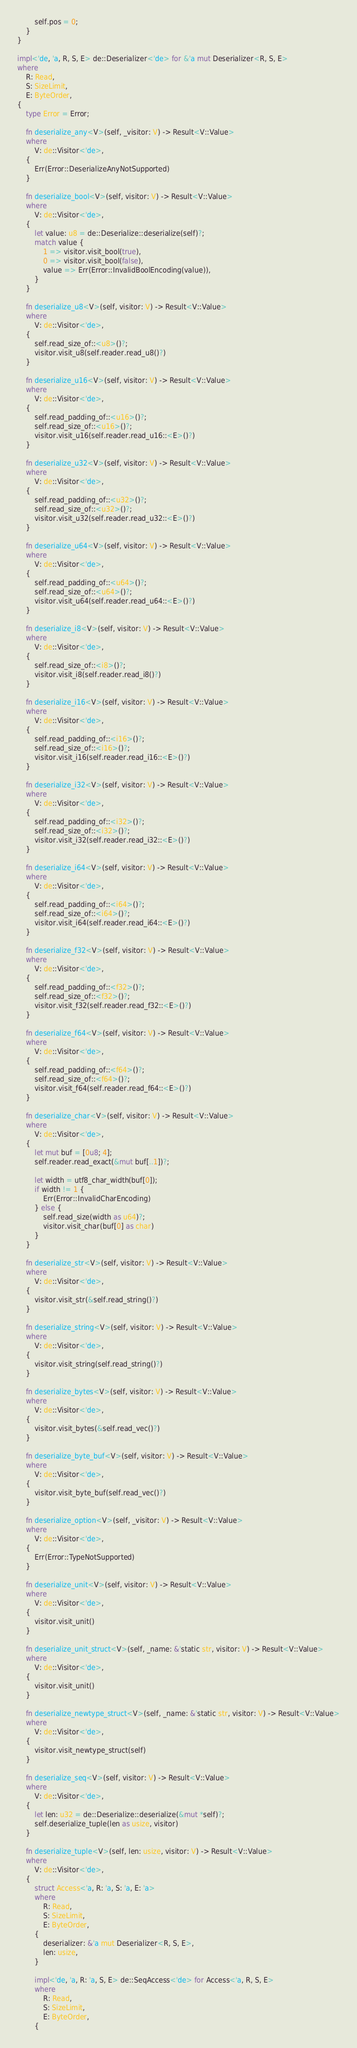Convert code to text. <code><loc_0><loc_0><loc_500><loc_500><_Rust_>        self.pos = 0;
    }
}

impl<'de, 'a, R, S, E> de::Deserializer<'de> for &'a mut Deserializer<R, S, E>
where
    R: Read,
    S: SizeLimit,
    E: ByteOrder,
{
    type Error = Error;

    fn deserialize_any<V>(self, _visitor: V) -> Result<V::Value>
    where
        V: de::Visitor<'de>,
    {
        Err(Error::DeserializeAnyNotSupported)
    }

    fn deserialize_bool<V>(self, visitor: V) -> Result<V::Value>
    where
        V: de::Visitor<'de>,
    {
        let value: u8 = de::Deserialize::deserialize(self)?;
        match value {
            1 => visitor.visit_bool(true),
            0 => visitor.visit_bool(false),
            value => Err(Error::InvalidBoolEncoding(value)),
        }
    }

    fn deserialize_u8<V>(self, visitor: V) -> Result<V::Value>
    where
        V: de::Visitor<'de>,
    {
        self.read_size_of::<u8>()?;
        visitor.visit_u8(self.reader.read_u8()?)
    }

    fn deserialize_u16<V>(self, visitor: V) -> Result<V::Value>
    where
        V: de::Visitor<'de>,
    {
        self.read_padding_of::<u16>()?;
        self.read_size_of::<u16>()?;
        visitor.visit_u16(self.reader.read_u16::<E>()?)
    }

    fn deserialize_u32<V>(self, visitor: V) -> Result<V::Value>
    where
        V: de::Visitor<'de>,
    {
        self.read_padding_of::<u32>()?;
        self.read_size_of::<u32>()?;
        visitor.visit_u32(self.reader.read_u32::<E>()?)
    }

    fn deserialize_u64<V>(self, visitor: V) -> Result<V::Value>
    where
        V: de::Visitor<'de>,
    {
        self.read_padding_of::<u64>()?;
        self.read_size_of::<u64>()?;
        visitor.visit_u64(self.reader.read_u64::<E>()?)
    }

    fn deserialize_i8<V>(self, visitor: V) -> Result<V::Value>
    where
        V: de::Visitor<'de>,
    {
        self.read_size_of::<i8>()?;
        visitor.visit_i8(self.reader.read_i8()?)
    }

    fn deserialize_i16<V>(self, visitor: V) -> Result<V::Value>
    where
        V: de::Visitor<'de>,
    {
        self.read_padding_of::<i16>()?;
        self.read_size_of::<i16>()?;
        visitor.visit_i16(self.reader.read_i16::<E>()?)
    }

    fn deserialize_i32<V>(self, visitor: V) -> Result<V::Value>
    where
        V: de::Visitor<'de>,
    {
        self.read_padding_of::<i32>()?;
        self.read_size_of::<i32>()?;
        visitor.visit_i32(self.reader.read_i32::<E>()?)
    }

    fn deserialize_i64<V>(self, visitor: V) -> Result<V::Value>
    where
        V: de::Visitor<'de>,
    {
        self.read_padding_of::<i64>()?;
        self.read_size_of::<i64>()?;
        visitor.visit_i64(self.reader.read_i64::<E>()?)
    }

    fn deserialize_f32<V>(self, visitor: V) -> Result<V::Value>
    where
        V: de::Visitor<'de>,
    {
        self.read_padding_of::<f32>()?;
        self.read_size_of::<f32>()?;
        visitor.visit_f32(self.reader.read_f32::<E>()?)
    }

    fn deserialize_f64<V>(self, visitor: V) -> Result<V::Value>
    where
        V: de::Visitor<'de>,
    {
        self.read_padding_of::<f64>()?;
        self.read_size_of::<f64>()?;
        visitor.visit_f64(self.reader.read_f64::<E>()?)
    }

    fn deserialize_char<V>(self, visitor: V) -> Result<V::Value>
    where
        V: de::Visitor<'de>,
    {
        let mut buf = [0u8; 4];
        self.reader.read_exact(&mut buf[..1])?;

        let width = utf8_char_width(buf[0]);
        if width != 1 {
            Err(Error::InvalidCharEncoding)
        } else {
            self.read_size(width as u64)?;
            visitor.visit_char(buf[0] as char)
        }
    }

    fn deserialize_str<V>(self, visitor: V) -> Result<V::Value>
    where
        V: de::Visitor<'de>,
    {
        visitor.visit_str(&self.read_string()?)
    }

    fn deserialize_string<V>(self, visitor: V) -> Result<V::Value>
    where
        V: de::Visitor<'de>,
    {
        visitor.visit_string(self.read_string()?)
    }

    fn deserialize_bytes<V>(self, visitor: V) -> Result<V::Value>
    where
        V: de::Visitor<'de>,
    {
        visitor.visit_bytes(&self.read_vec()?)
    }

    fn deserialize_byte_buf<V>(self, visitor: V) -> Result<V::Value>
    where
        V: de::Visitor<'de>,
    {
        visitor.visit_byte_buf(self.read_vec()?)
    }

    fn deserialize_option<V>(self, _visitor: V) -> Result<V::Value>
    where
        V: de::Visitor<'de>,
    {
        Err(Error::TypeNotSupported)
    }

    fn deserialize_unit<V>(self, visitor: V) -> Result<V::Value>
    where
        V: de::Visitor<'de>,
    {
        visitor.visit_unit()
    }

    fn deserialize_unit_struct<V>(self, _name: &'static str, visitor: V) -> Result<V::Value>
    where
        V: de::Visitor<'de>,
    {
        visitor.visit_unit()
    }

    fn deserialize_newtype_struct<V>(self, _name: &'static str, visitor: V) -> Result<V::Value>
    where
        V: de::Visitor<'de>,
    {
        visitor.visit_newtype_struct(self)
    }

    fn deserialize_seq<V>(self, visitor: V) -> Result<V::Value>
    where
        V: de::Visitor<'de>,
    {
        let len: u32 = de::Deserialize::deserialize(&mut *self)?;
        self.deserialize_tuple(len as usize, visitor)
    }

    fn deserialize_tuple<V>(self, len: usize, visitor: V) -> Result<V::Value>
    where
        V: de::Visitor<'de>,
    {
        struct Access<'a, R: 'a, S: 'a, E: 'a>
        where
            R: Read,
            S: SizeLimit,
            E: ByteOrder,
        {
            deserializer: &'a mut Deserializer<R, S, E>,
            len: usize,
        }

        impl<'de, 'a, R: 'a, S, E> de::SeqAccess<'de> for Access<'a, R, S, E>
        where
            R: Read,
            S: SizeLimit,
            E: ByteOrder,
        {</code> 